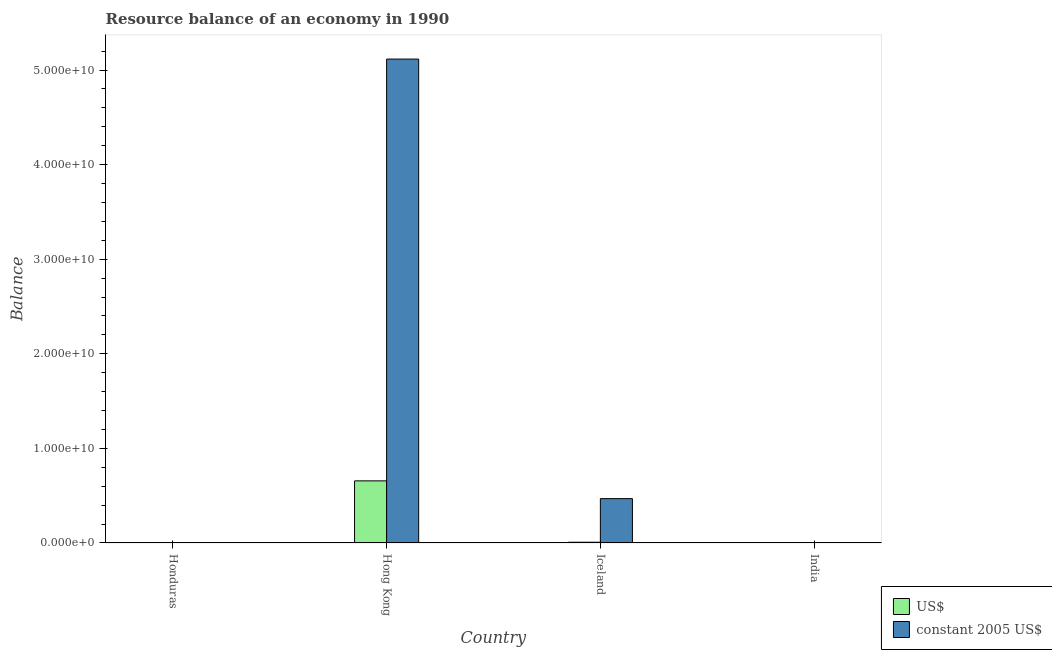How many bars are there on the 4th tick from the left?
Make the answer very short. 0. How many bars are there on the 1st tick from the right?
Offer a terse response. 0. What is the label of the 2nd group of bars from the left?
Your answer should be very brief. Hong Kong. In how many cases, is the number of bars for a given country not equal to the number of legend labels?
Your response must be concise. 2. What is the resource balance in constant us$ in Hong Kong?
Ensure brevity in your answer.  5.12e+1. Across all countries, what is the maximum resource balance in constant us$?
Keep it short and to the point. 5.12e+1. Across all countries, what is the minimum resource balance in us$?
Make the answer very short. 0. In which country was the resource balance in us$ maximum?
Offer a very short reply. Hong Kong. What is the total resource balance in us$ in the graph?
Your answer should be very brief. 6.65e+09. What is the difference between the resource balance in us$ in Hong Kong and that in Iceland?
Give a very brief answer. 6.49e+09. What is the difference between the resource balance in constant us$ in Honduras and the resource balance in us$ in India?
Ensure brevity in your answer.  0. What is the average resource balance in constant us$ per country?
Offer a very short reply. 1.40e+1. What is the difference between the resource balance in constant us$ and resource balance in us$ in Hong Kong?
Provide a short and direct response. 4.46e+1. In how many countries, is the resource balance in constant us$ greater than 46000000000 units?
Your answer should be compact. 1. What is the ratio of the resource balance in us$ in Hong Kong to that in Iceland?
Make the answer very short. 81.62. Is the resource balance in us$ in Hong Kong less than that in Iceland?
Give a very brief answer. No. What is the difference between the highest and the lowest resource balance in us$?
Ensure brevity in your answer.  6.57e+09. In how many countries, is the resource balance in constant us$ greater than the average resource balance in constant us$ taken over all countries?
Give a very brief answer. 1. Is the sum of the resource balance in us$ in Hong Kong and Iceland greater than the maximum resource balance in constant us$ across all countries?
Your answer should be very brief. No. How many bars are there?
Your response must be concise. 4. What is the difference between two consecutive major ticks on the Y-axis?
Ensure brevity in your answer.  1.00e+1. Are the values on the major ticks of Y-axis written in scientific E-notation?
Your response must be concise. Yes. Does the graph contain grids?
Give a very brief answer. No. How many legend labels are there?
Offer a terse response. 2. What is the title of the graph?
Provide a short and direct response. Resource balance of an economy in 1990. Does "IMF nonconcessional" appear as one of the legend labels in the graph?
Your response must be concise. No. What is the label or title of the Y-axis?
Keep it short and to the point. Balance. What is the Balance of US$ in Honduras?
Make the answer very short. 0. What is the Balance of US$ in Hong Kong?
Provide a succinct answer. 6.57e+09. What is the Balance in constant 2005 US$ in Hong Kong?
Your response must be concise. 5.12e+1. What is the Balance of US$ in Iceland?
Keep it short and to the point. 8.05e+07. What is the Balance of constant 2005 US$ in Iceland?
Make the answer very short. 4.69e+09. What is the Balance in constant 2005 US$ in India?
Provide a short and direct response. 0. Across all countries, what is the maximum Balance in US$?
Give a very brief answer. 6.57e+09. Across all countries, what is the maximum Balance in constant 2005 US$?
Your answer should be compact. 5.12e+1. Across all countries, what is the minimum Balance in US$?
Make the answer very short. 0. What is the total Balance of US$ in the graph?
Your answer should be very brief. 6.65e+09. What is the total Balance of constant 2005 US$ in the graph?
Ensure brevity in your answer.  5.59e+1. What is the difference between the Balance of US$ in Hong Kong and that in Iceland?
Make the answer very short. 6.49e+09. What is the difference between the Balance of constant 2005 US$ in Hong Kong and that in Iceland?
Ensure brevity in your answer.  4.65e+1. What is the difference between the Balance in US$ in Hong Kong and the Balance in constant 2005 US$ in Iceland?
Your answer should be compact. 1.88e+09. What is the average Balance of US$ per country?
Offer a very short reply. 1.66e+09. What is the average Balance of constant 2005 US$ per country?
Your answer should be compact. 1.40e+1. What is the difference between the Balance of US$ and Balance of constant 2005 US$ in Hong Kong?
Give a very brief answer. -4.46e+1. What is the difference between the Balance in US$ and Balance in constant 2005 US$ in Iceland?
Give a very brief answer. -4.61e+09. What is the ratio of the Balance of US$ in Hong Kong to that in Iceland?
Provide a short and direct response. 81.62. What is the ratio of the Balance in constant 2005 US$ in Hong Kong to that in Iceland?
Give a very brief answer. 10.91. What is the difference between the highest and the lowest Balance of US$?
Your answer should be very brief. 6.57e+09. What is the difference between the highest and the lowest Balance of constant 2005 US$?
Your answer should be very brief. 5.12e+1. 